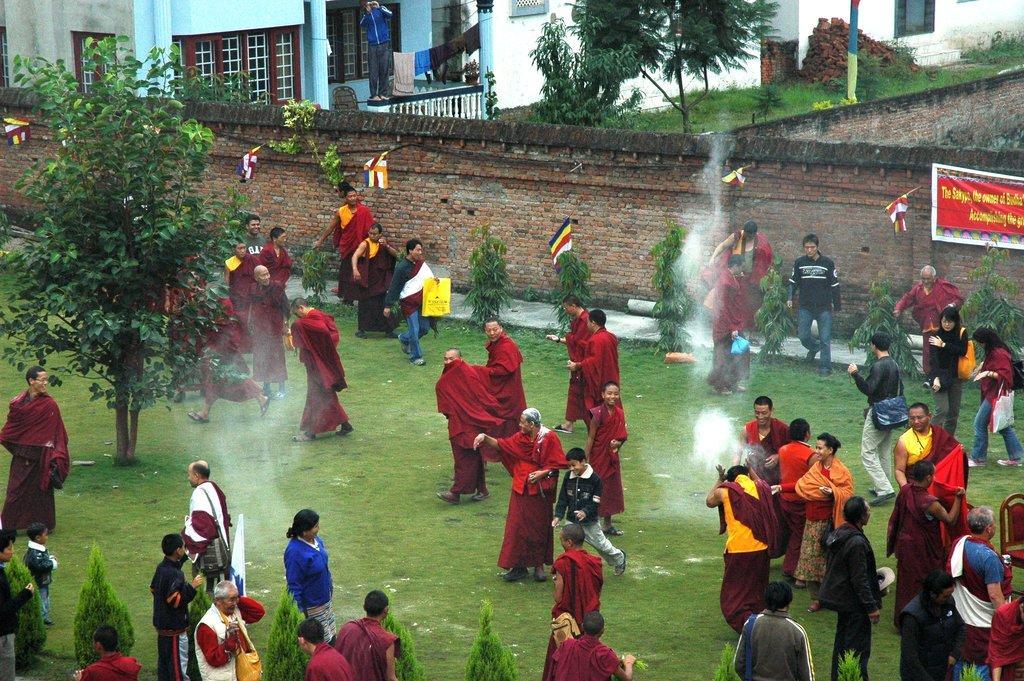How would you summarize this image in a sentence or two? In this image I can see people on the ground among them some are wearing red color clothes. Here I can see a wall, buildings, trees, the grass, flags and a banner on the wall. 